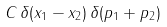Convert formula to latex. <formula><loc_0><loc_0><loc_500><loc_500>C \, \delta ( x _ { 1 } - x _ { 2 } ) \, \delta ( p _ { 1 } + p _ { 2 } )</formula> 